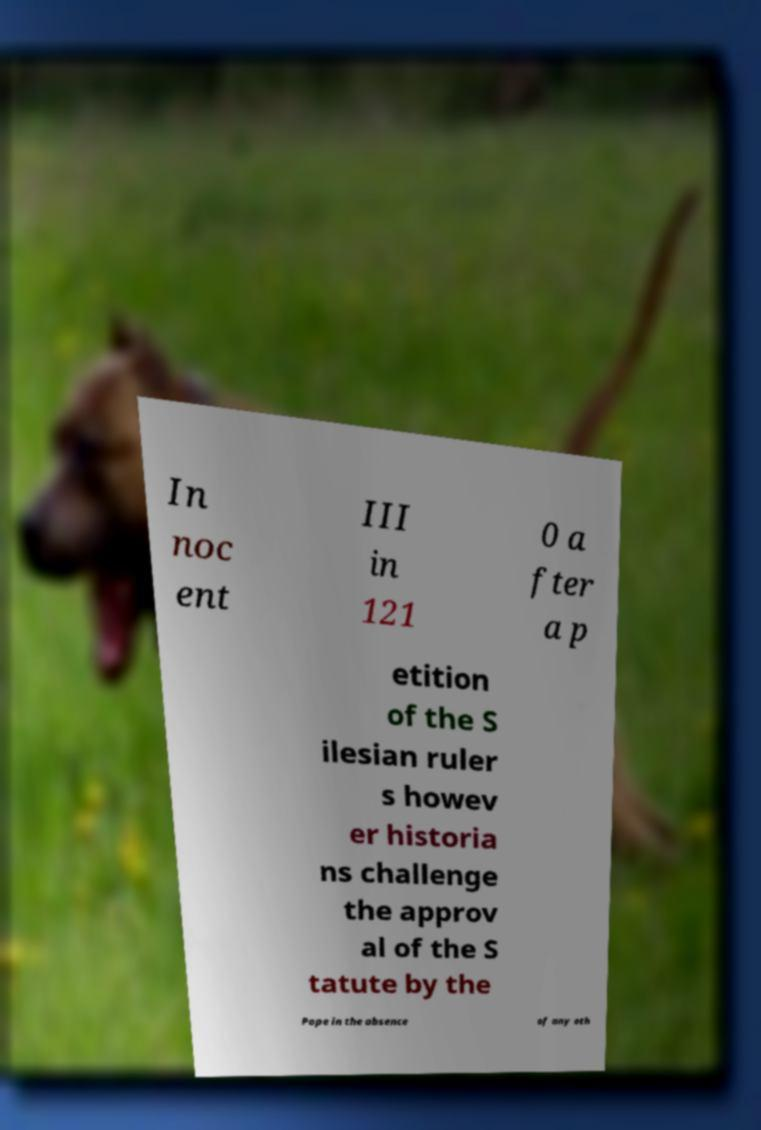I need the written content from this picture converted into text. Can you do that? In noc ent III in 121 0 a fter a p etition of the S ilesian ruler s howev er historia ns challenge the approv al of the S tatute by the Pope in the absence of any oth 